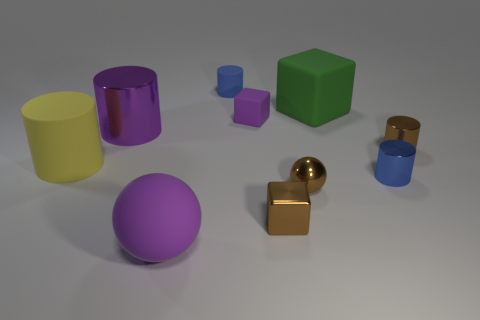What size is the object that is left of the tiny purple object and on the right side of the big purple ball?
Offer a very short reply. Small. What is the material of the brown cube that is the same size as the brown cylinder?
Offer a terse response. Metal. There is a matte cylinder that is left of the sphere on the left side of the tiny matte block; what number of large purple matte balls are in front of it?
Your response must be concise. 1. Does the tiny cube that is to the right of the tiny purple block have the same color as the small shiny thing behind the yellow cylinder?
Offer a terse response. Yes. What is the color of the large thing that is both to the left of the small blue rubber object and on the right side of the large purple cylinder?
Make the answer very short. Purple. What number of purple matte spheres have the same size as the yellow object?
Provide a succinct answer. 1. What shape is the metal thing right of the tiny blue cylinder that is in front of the purple matte block?
Your answer should be compact. Cylinder. There is a matte thing that is left of the shiny cylinder that is on the left side of the blue object left of the tiny purple thing; what is its shape?
Make the answer very short. Cylinder. How many big green matte things have the same shape as the big yellow object?
Offer a terse response. 0. What number of tiny blue cylinders are in front of the cylinder to the left of the purple cylinder?
Give a very brief answer. 1. 